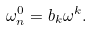<formula> <loc_0><loc_0><loc_500><loc_500>\omega _ { n } ^ { 0 } = b _ { k } \omega ^ { k } .</formula> 